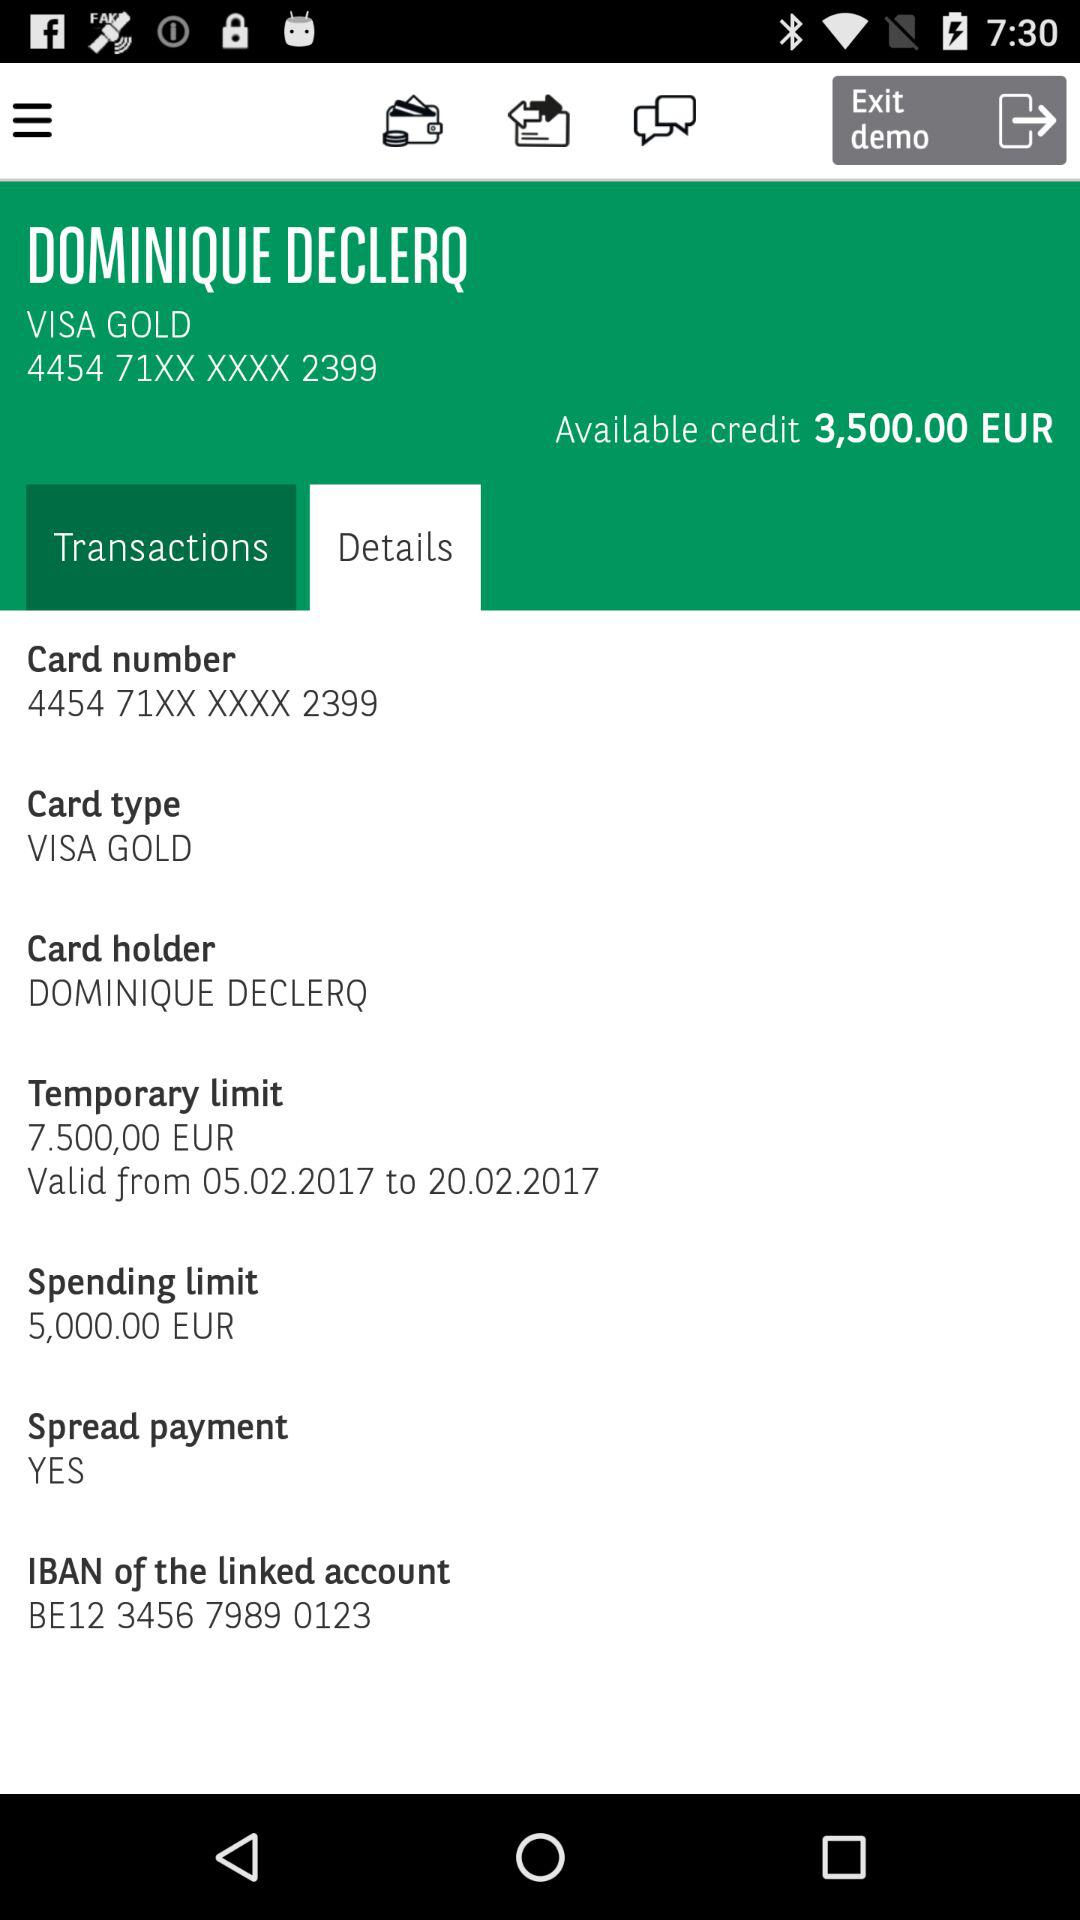What is the card type? The card type is "VISA GOLD". 